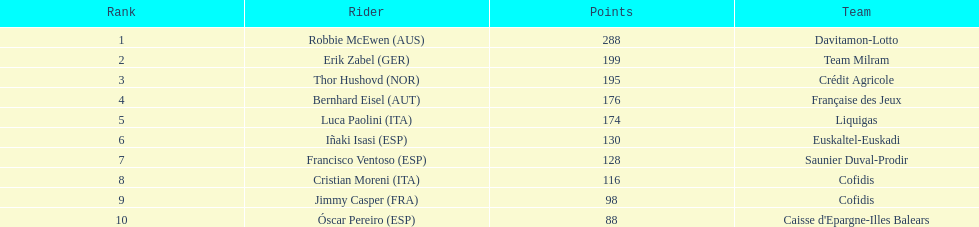How many points did robbie mcewen and cristian moreni score together? 404. 